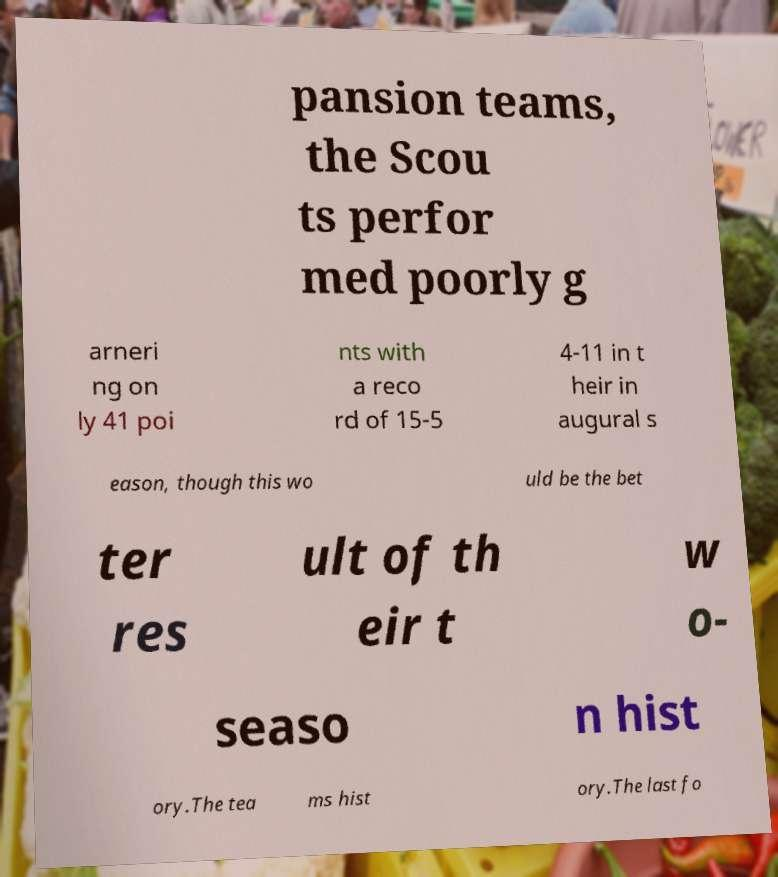Can you read and provide the text displayed in the image?This photo seems to have some interesting text. Can you extract and type it out for me? pansion teams, the Scou ts perfor med poorly g arneri ng on ly 41 poi nts with a reco rd of 15-5 4-11 in t heir in augural s eason, though this wo uld be the bet ter res ult of th eir t w o- seaso n hist ory.The tea ms hist ory.The last fo 